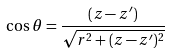Convert formula to latex. <formula><loc_0><loc_0><loc_500><loc_500>\cos \theta = \frac { ( z - z ^ { \prime } ) } { \sqrt { r ^ { 2 } + ( z - z ^ { \prime } ) ^ { 2 } } }</formula> 